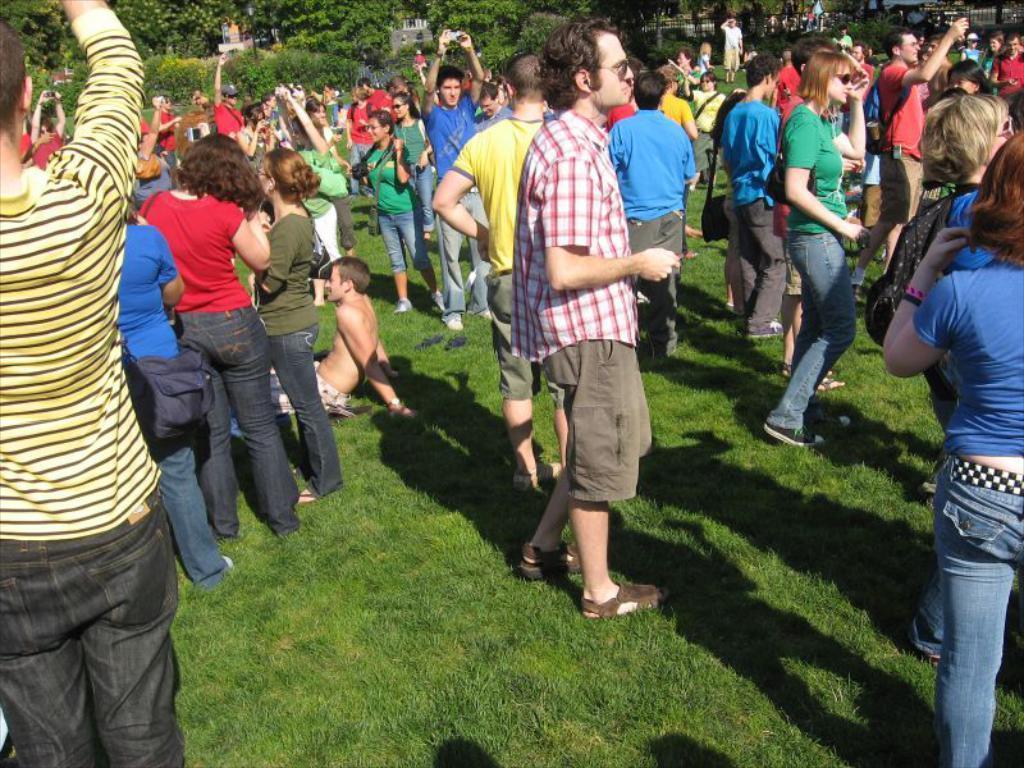Could you give a brief overview of what you see in this image? In this picture I can see there are a few people standing and there is a man sitting on the floor to the left and there is grass on the floor. There is a huge crowd of people standing, they raised their hands up. In the backdrop, there are trees, it looks like there are buildings. 